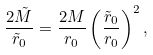<formula> <loc_0><loc_0><loc_500><loc_500>\frac { 2 \tilde { M } } { \tilde { r } _ { 0 } } = \frac { 2 M } { r _ { 0 } } \left ( \frac { \tilde { r } _ { 0 } } { r _ { 0 } } \right ) ^ { 2 } ,</formula> 